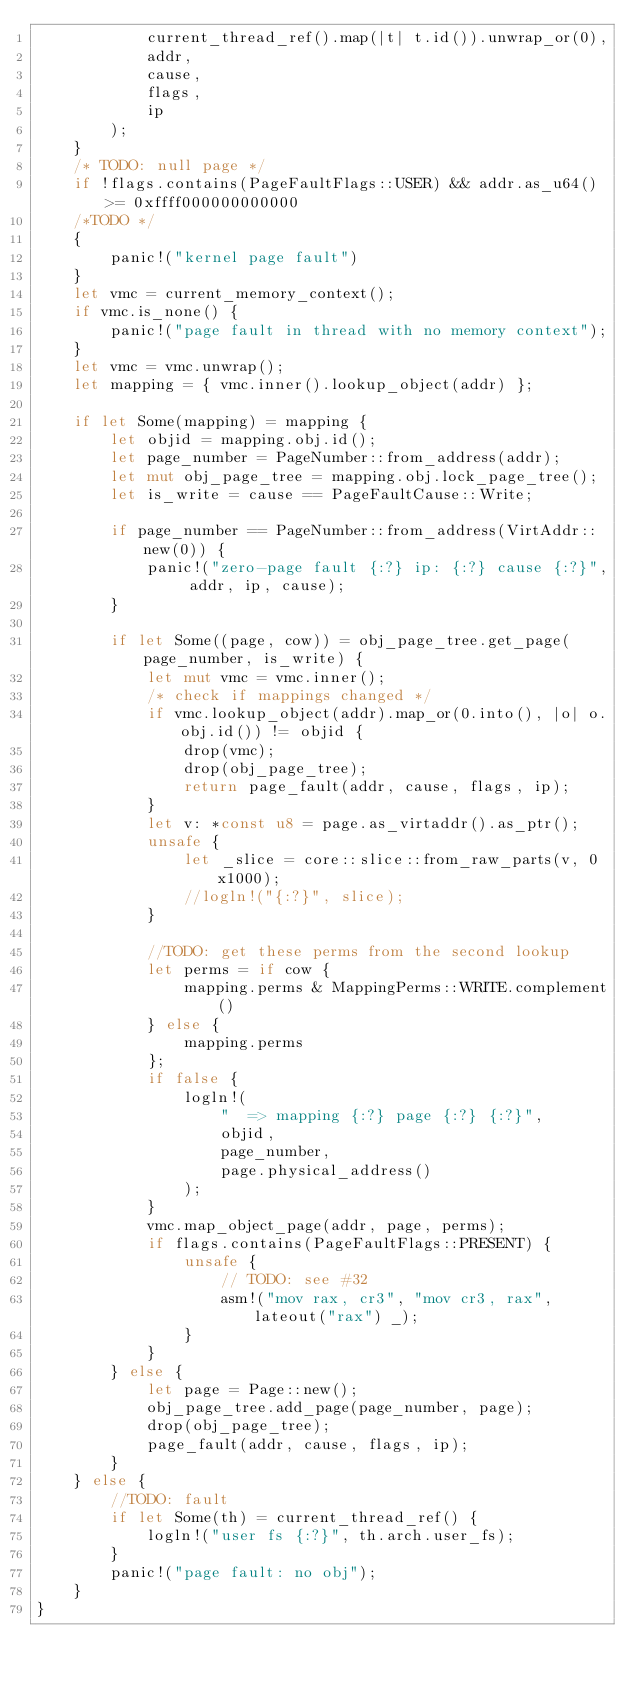Convert code to text. <code><loc_0><loc_0><loc_500><loc_500><_Rust_>            current_thread_ref().map(|t| t.id()).unwrap_or(0),
            addr,
            cause,
            flags,
            ip
        );
    }
    /* TODO: null page */
    if !flags.contains(PageFaultFlags::USER) && addr.as_u64() >= 0xffff000000000000
    /*TODO */
    {
        panic!("kernel page fault")
    }
    let vmc = current_memory_context();
    if vmc.is_none() {
        panic!("page fault in thread with no memory context");
    }
    let vmc = vmc.unwrap();
    let mapping = { vmc.inner().lookup_object(addr) };

    if let Some(mapping) = mapping {
        let objid = mapping.obj.id();
        let page_number = PageNumber::from_address(addr);
        let mut obj_page_tree = mapping.obj.lock_page_tree();
        let is_write = cause == PageFaultCause::Write;

        if page_number == PageNumber::from_address(VirtAddr::new(0)) {
            panic!("zero-page fault {:?} ip: {:?} cause {:?}", addr, ip, cause);
        }

        if let Some((page, cow)) = obj_page_tree.get_page(page_number, is_write) {
            let mut vmc = vmc.inner();
            /* check if mappings changed */
            if vmc.lookup_object(addr).map_or(0.into(), |o| o.obj.id()) != objid {
                drop(vmc);
                drop(obj_page_tree);
                return page_fault(addr, cause, flags, ip);
            }
            let v: *const u8 = page.as_virtaddr().as_ptr();
            unsafe {
                let _slice = core::slice::from_raw_parts(v, 0x1000);
                //logln!("{:?}", slice);
            }

            //TODO: get these perms from the second lookup
            let perms = if cow {
                mapping.perms & MappingPerms::WRITE.complement()
            } else {
                mapping.perms
            };
            if false {
                logln!(
                    "  => mapping {:?} page {:?} {:?}",
                    objid,
                    page_number,
                    page.physical_address()
                );
            }
            vmc.map_object_page(addr, page, perms);
            if flags.contains(PageFaultFlags::PRESENT) {
                unsafe {
                    // TODO: see #32
                    asm!("mov rax, cr3", "mov cr3, rax", lateout("rax") _);
                }
            }
        } else {
            let page = Page::new();
            obj_page_tree.add_page(page_number, page);
            drop(obj_page_tree);
            page_fault(addr, cause, flags, ip);
        }
    } else {
        //TODO: fault
        if let Some(th) = current_thread_ref() {
            logln!("user fs {:?}", th.arch.user_fs);
        }
        panic!("page fault: no obj");
    }
}
</code> 